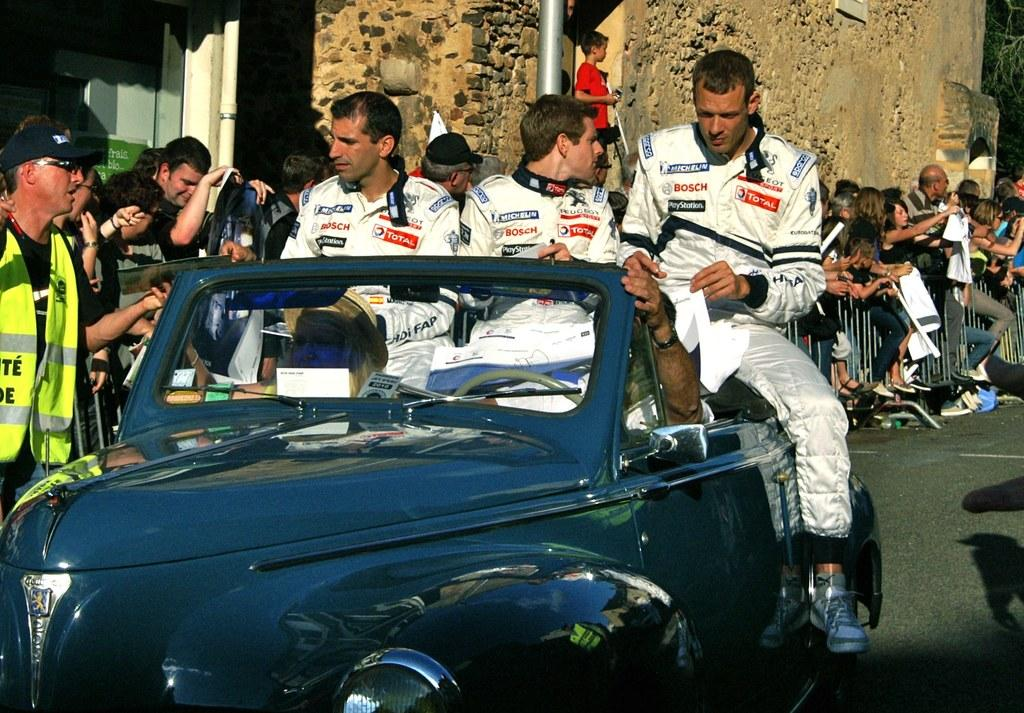What is the main subject of the image? The main subject of the image is a car. What are the people in the image doing? There are people sitting on the car. What can be seen in the background of the image? There are people standing on the sidewalk and a wall visible in the background. What type of jam is being spread on the car in the image? There is no jam present in the image, and therefore no such activity can be observed. 